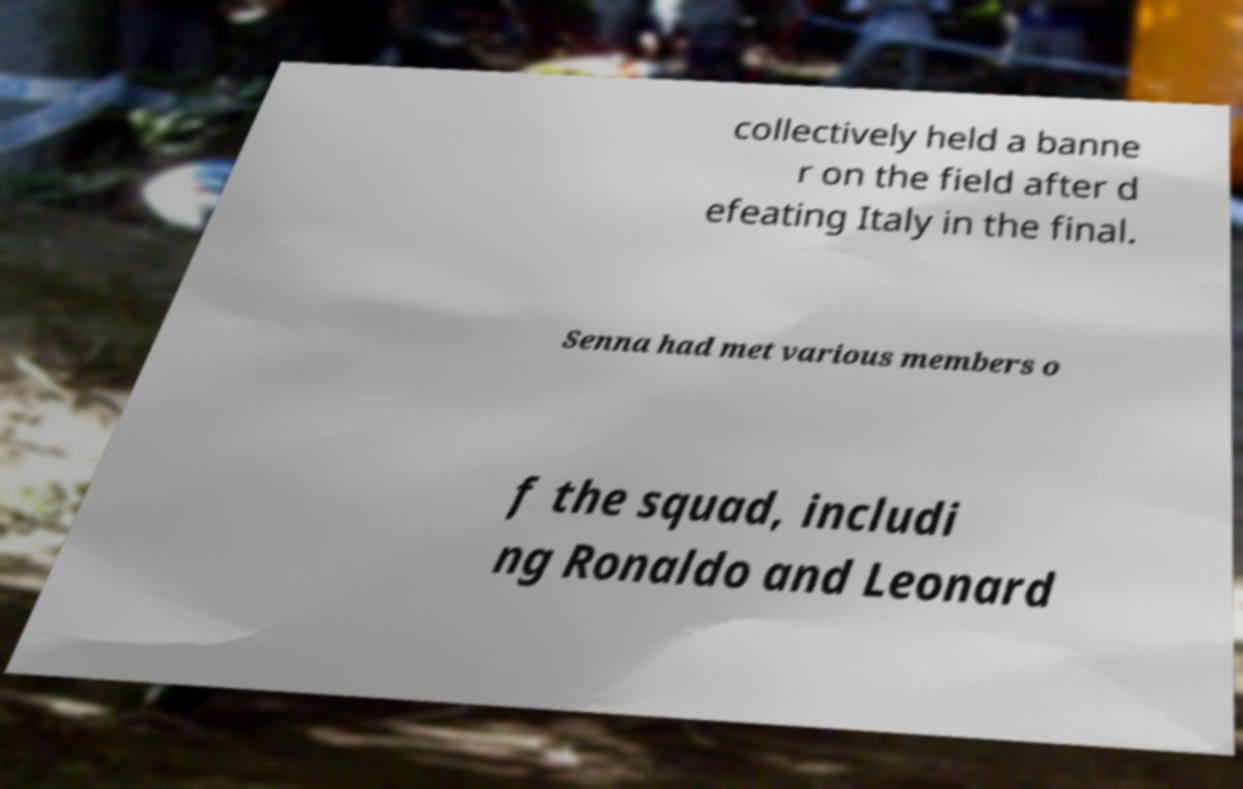Could you extract and type out the text from this image? collectively held a banne r on the field after d efeating Italy in the final. Senna had met various members o f the squad, includi ng Ronaldo and Leonard 